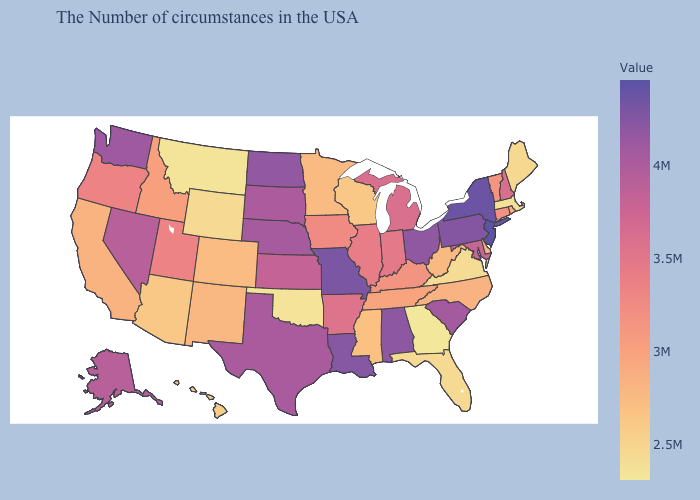Which states have the lowest value in the West?
Write a very short answer. Montana. Does the map have missing data?
Give a very brief answer. No. Which states have the highest value in the USA?
Quick response, please. New Jersey. Among the states that border Montana , which have the highest value?
Give a very brief answer. North Dakota. Among the states that border Wisconsin , does Iowa have the lowest value?
Keep it brief. No. Which states have the highest value in the USA?
Be succinct. New Jersey. 